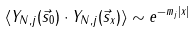<formula> <loc_0><loc_0><loc_500><loc_500>\langle Y _ { N , j } ( \vec { s } _ { 0 } ) \cdot Y _ { N , j } ( \vec { s } _ { x } ) \rangle \sim e ^ { - m _ { j } | x | }</formula> 